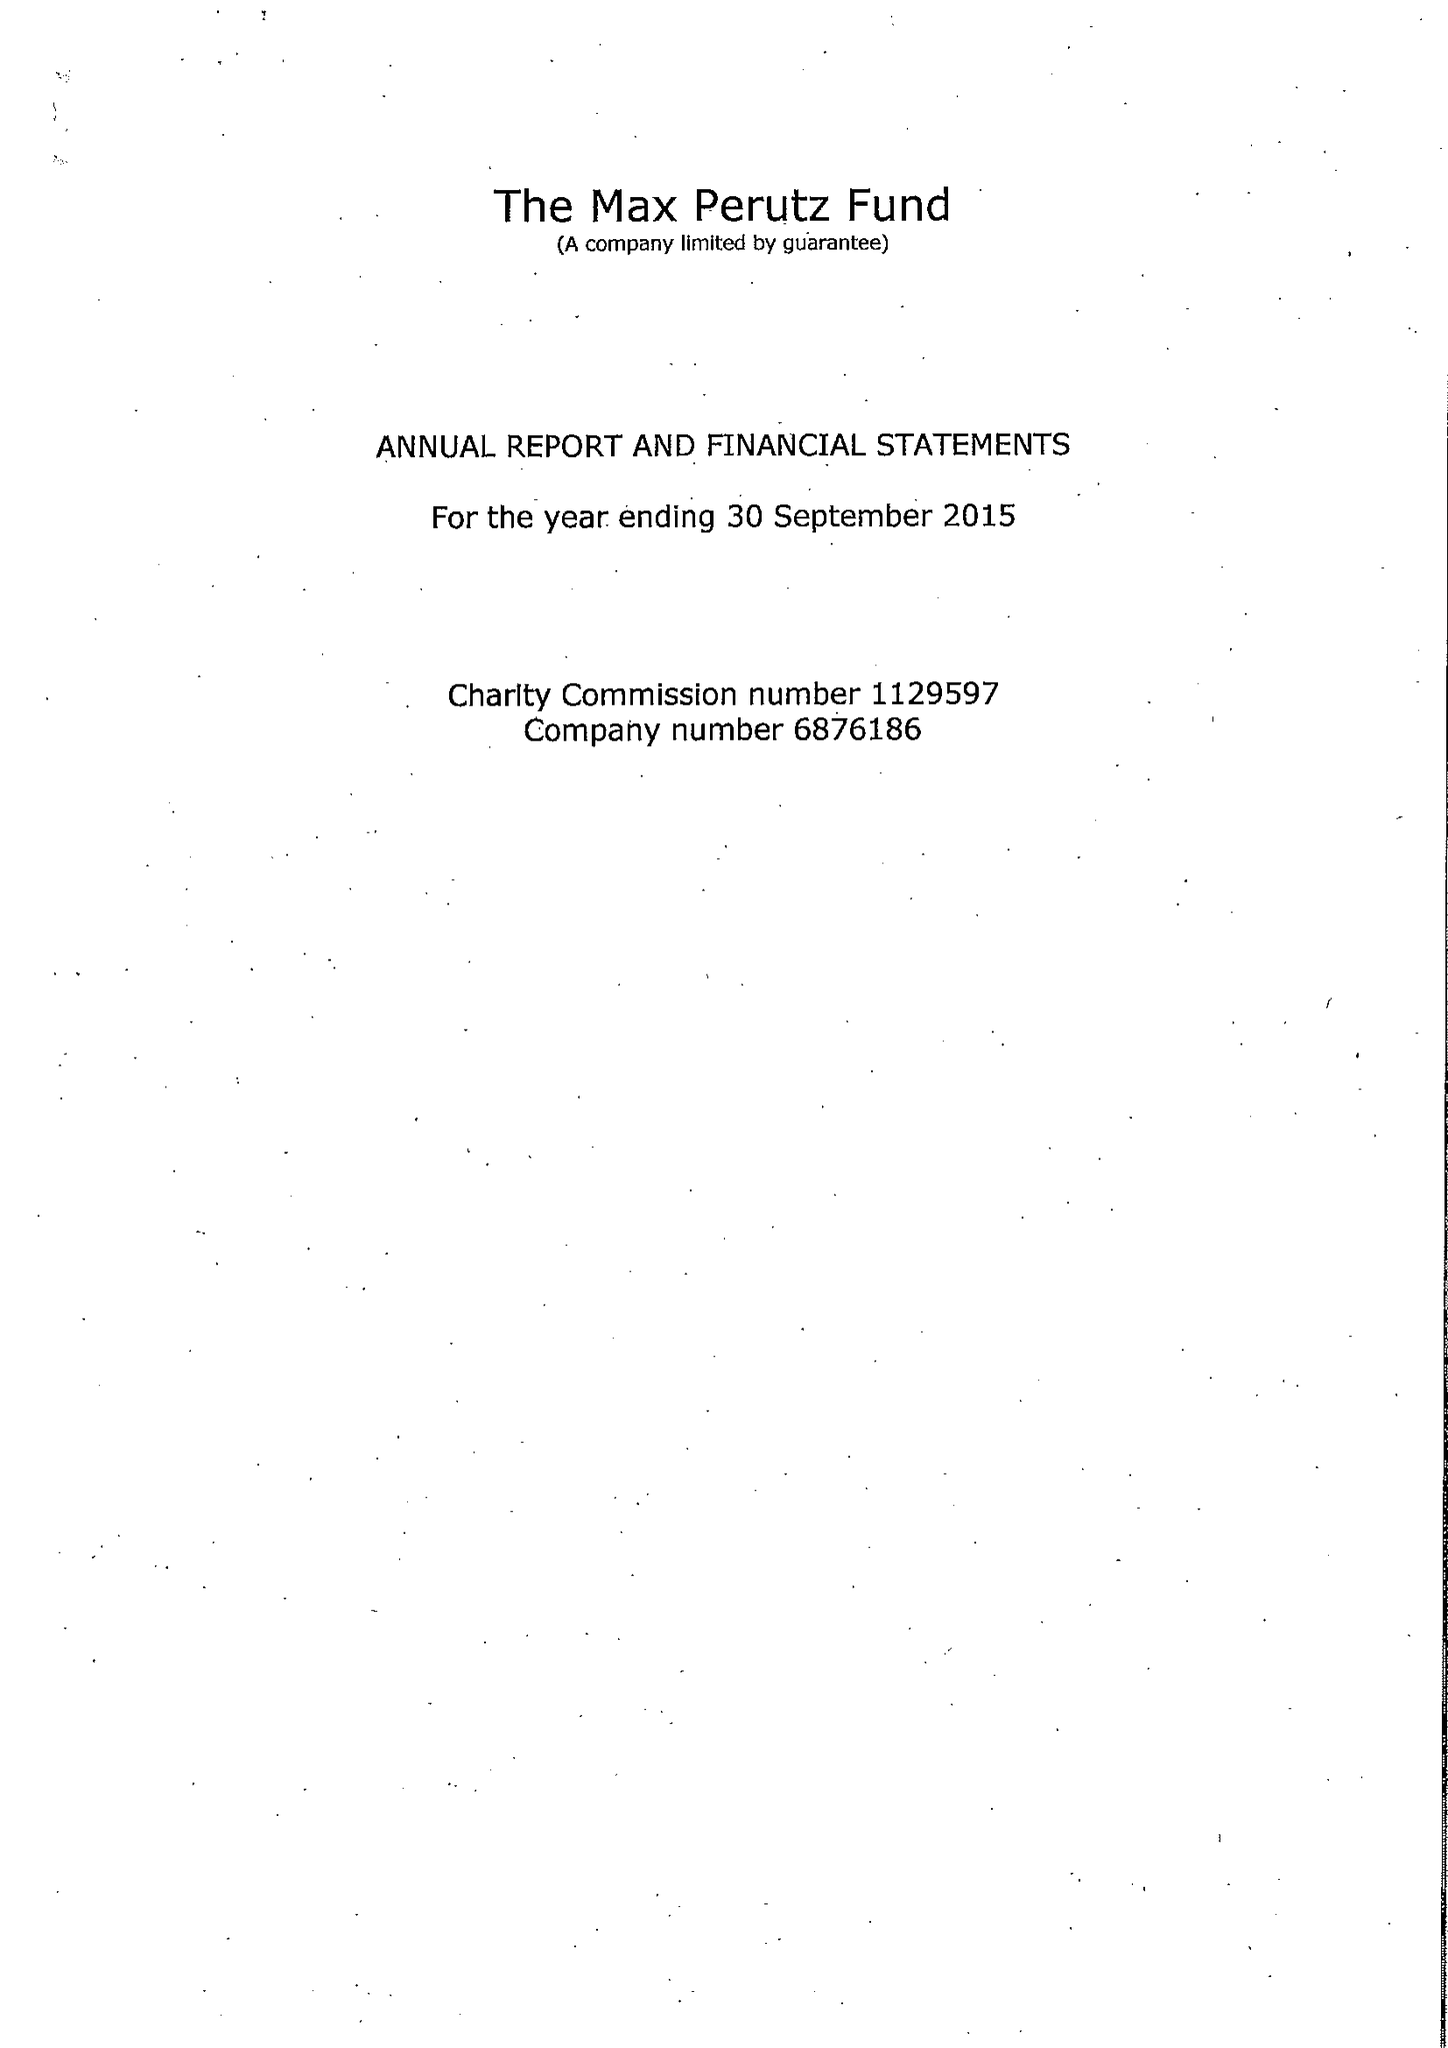What is the value for the income_annually_in_british_pounds?
Answer the question using a single word or phrase. 223046.00 